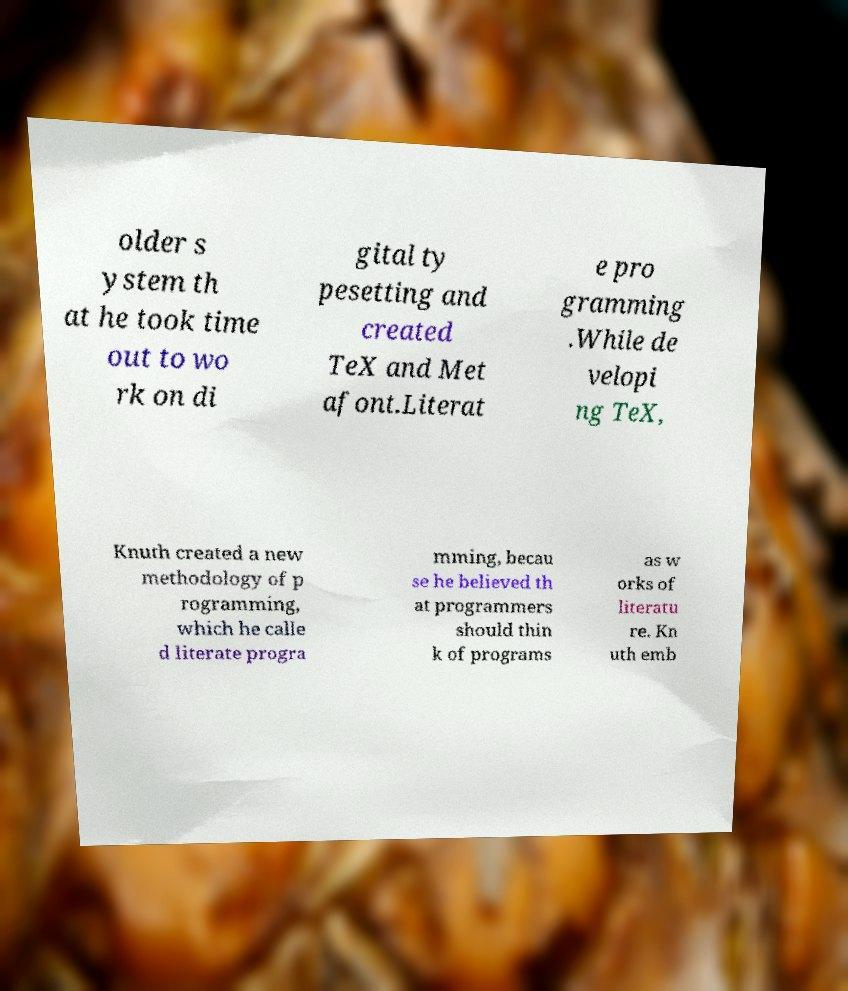Please read and relay the text visible in this image. What does it say? older s ystem th at he took time out to wo rk on di gital ty pesetting and created TeX and Met afont.Literat e pro gramming .While de velopi ng TeX, Knuth created a new methodology of p rogramming, which he calle d literate progra mming, becau se he believed th at programmers should thin k of programs as w orks of literatu re. Kn uth emb 